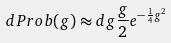<formula> <loc_0><loc_0><loc_500><loc_500>d P r o b ( g ) \approx d g \frac { g } { 2 } e ^ { - \frac { 1 } { 4 } g ^ { 2 } }</formula> 